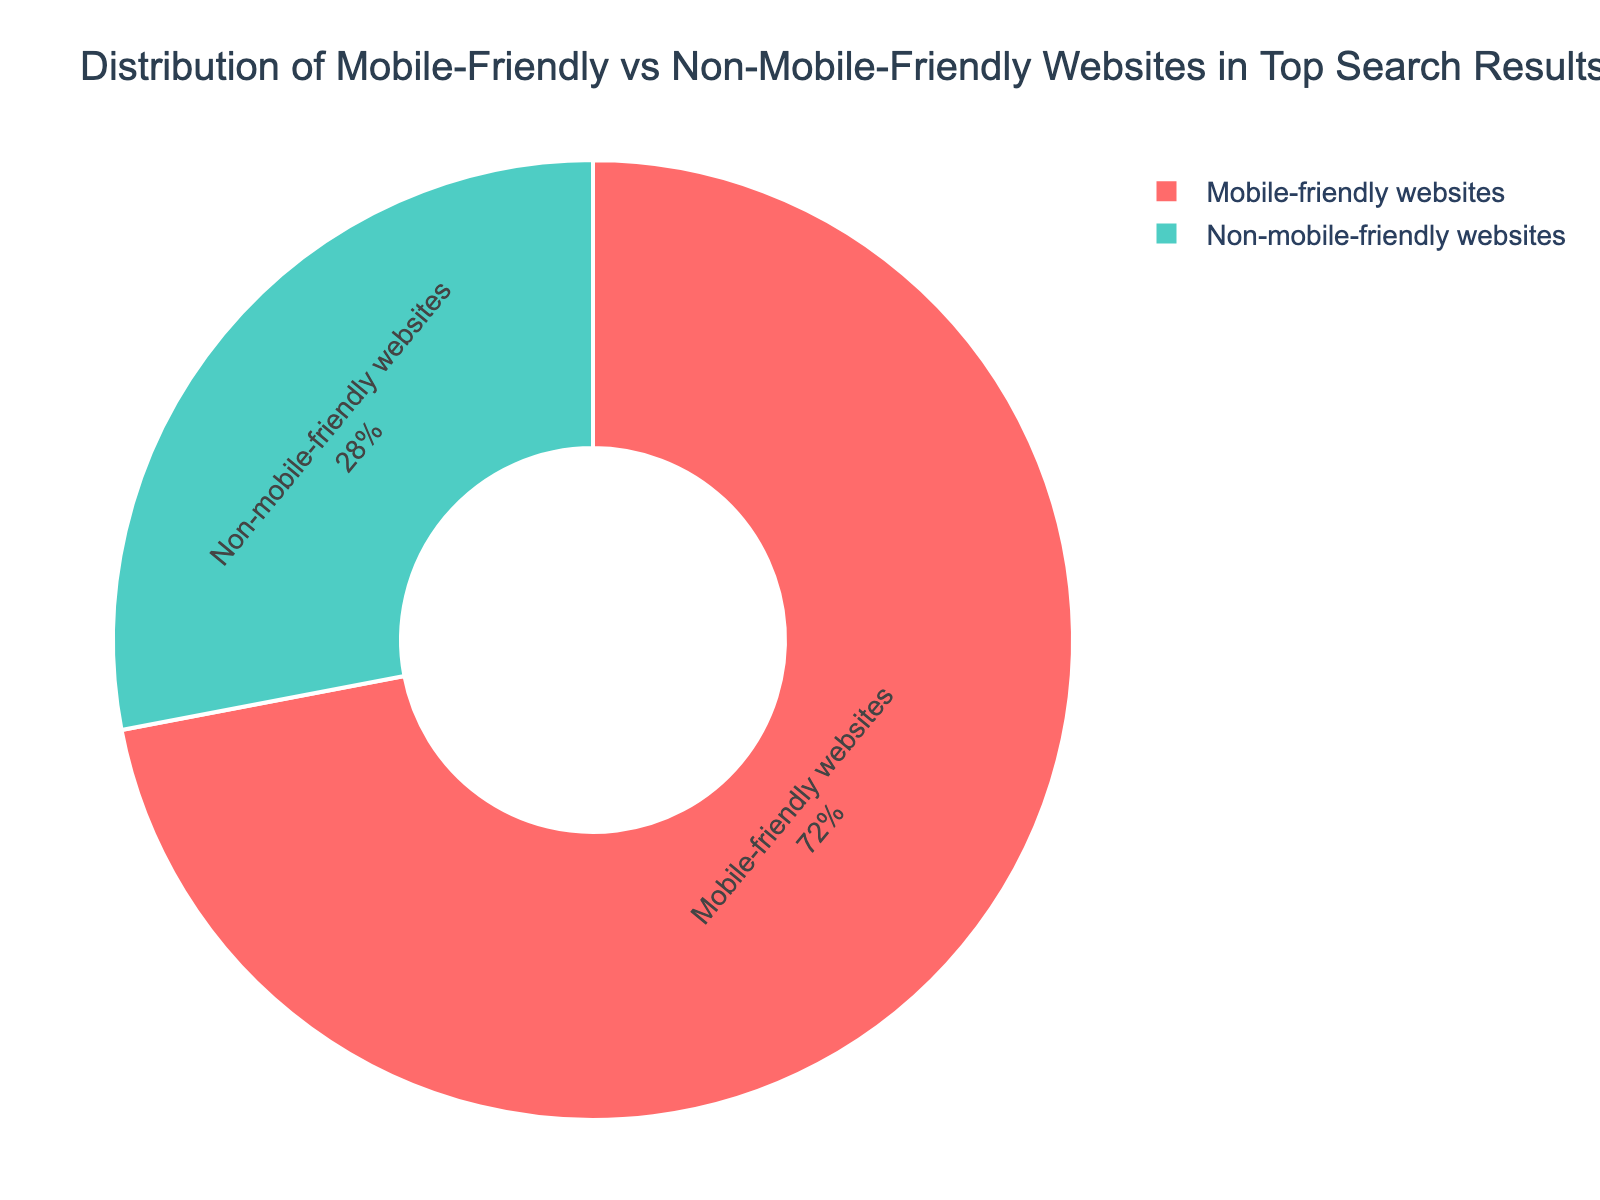What percentage of websites in the top search results are mobile-friendly? By examining the pie chart, the segment labeled "Mobile-friendly websites" shows a percentage of 72%.
Answer: 72% What percentage of websites in the top search results are non-mobile-friendly? By examining the pie chart, the segment labeled "Non-mobile-friendly websites" shows a percentage of 28%.
Answer: 28% Is the majority of websites in the top search results mobile-friendly or non-mobile-friendly? The segment of the pie chart labeled "Mobile-friendly websites" occupies a larger portion of the chart (72%) compared to "Non-mobile-friendly websites" (28%), so the majority are mobile-friendly.
Answer: Mobile-friendly How many times greater is the percentage of mobile-friendly websites compared to non-mobile-friendly websites? The percentage of mobile-friendly websites is 72%, and the percentage of non-mobile-friendly websites is 28%. To find how many times greater, divide 72 by 28: 72 / 28 = 2.57.
Answer: Approximately 2.57 times If 1,000 websites were analyzed, how many of them would be mobile-friendly? Given that 72% of the websites are mobile-friendly, calculate 72% of 1,000: \( (72/100) \times 1,000 = 720 \).
Answer: 720 If the percentages of mobile-friendly and non-mobile-friendly websites were to be represented as a ratio, what would it be? The percentages are 72% for mobile-friendly and 28% for non-mobile-friendly. Thus, the ratio is 72:28. Simplify this by dividing both numbers by their greatest common divisor, 4: \(\frac{72}{4} : \frac{28}{4} = 18 : 7\).
Answer: 18:7 What is the difference in percentage between mobile-friendly and non-mobile-friendly websites? The percentage of mobile-friendly websites is 72% and non-mobile-friendly websites is 28%. Subtract the smaller percentage from the larger one: 72% - 28% = 44%.
Answer: 44% Which category is represented by the green-colored segment in the pie chart? By observing the chart, the green-colored segment represents "Non-mobile-friendly websites."
Answer: Non-mobile-friendly websites If the proportion of mobile-friendly websites increased by 10%, what would be their new percentage? Starting with 72%, an increase of 10% yields \(72 + 10 = 82\)%.
Answer: 82% If 200 more non-mobile-friendly websites were converted to mobile-friendly, how would the percentages change (assuming the total remains 1,000 websites)? Currently, 280 websites are non-mobile-friendly and 720 are mobile-friendly (since 28% of 1,000 is 280 and 72% of 1,000 is 720). Converting 200 non-mobile-friendly websites to mobile-friendly means mobile-friendly websites increase to \(720 + 200 = 920\) and non-mobile-friendly decrease to \(280 - 200 = 80\). The new percentages are: \((920 / 1,000) \times 100 = 92\)% for mobile-friendly and \((80 / 1,000) \times 100 = 8\)% for non-mobile-friendly.
Answer: 92% for mobile-friendly and 8% for non-mobile-friendly 